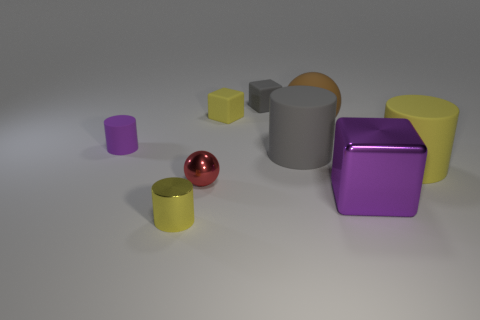What is the shape of the small thing that is the same color as the large metal block?
Your answer should be compact. Cylinder. What size is the gray block that is made of the same material as the big ball?
Give a very brief answer. Small. What size is the rubber cylinder that is the same color as the large shiny thing?
Your answer should be very brief. Small. Does the metallic cylinder have the same color as the tiny metal sphere?
Make the answer very short. No. There is a large cylinder that is to the left of the large rubber thing that is behind the small rubber cylinder; is there a tiny gray cube that is in front of it?
Keep it short and to the point. No. What number of red balls have the same size as the yellow rubber cylinder?
Ensure brevity in your answer.  0. Is the size of the thing behind the yellow matte cube the same as the yellow rubber object that is to the right of the small gray thing?
Provide a short and direct response. No. What is the shape of the big matte object that is both in front of the tiny purple object and left of the metallic cube?
Give a very brief answer. Cylinder. Is there a large object of the same color as the big shiny block?
Give a very brief answer. No. Are any big brown spheres visible?
Ensure brevity in your answer.  Yes. 